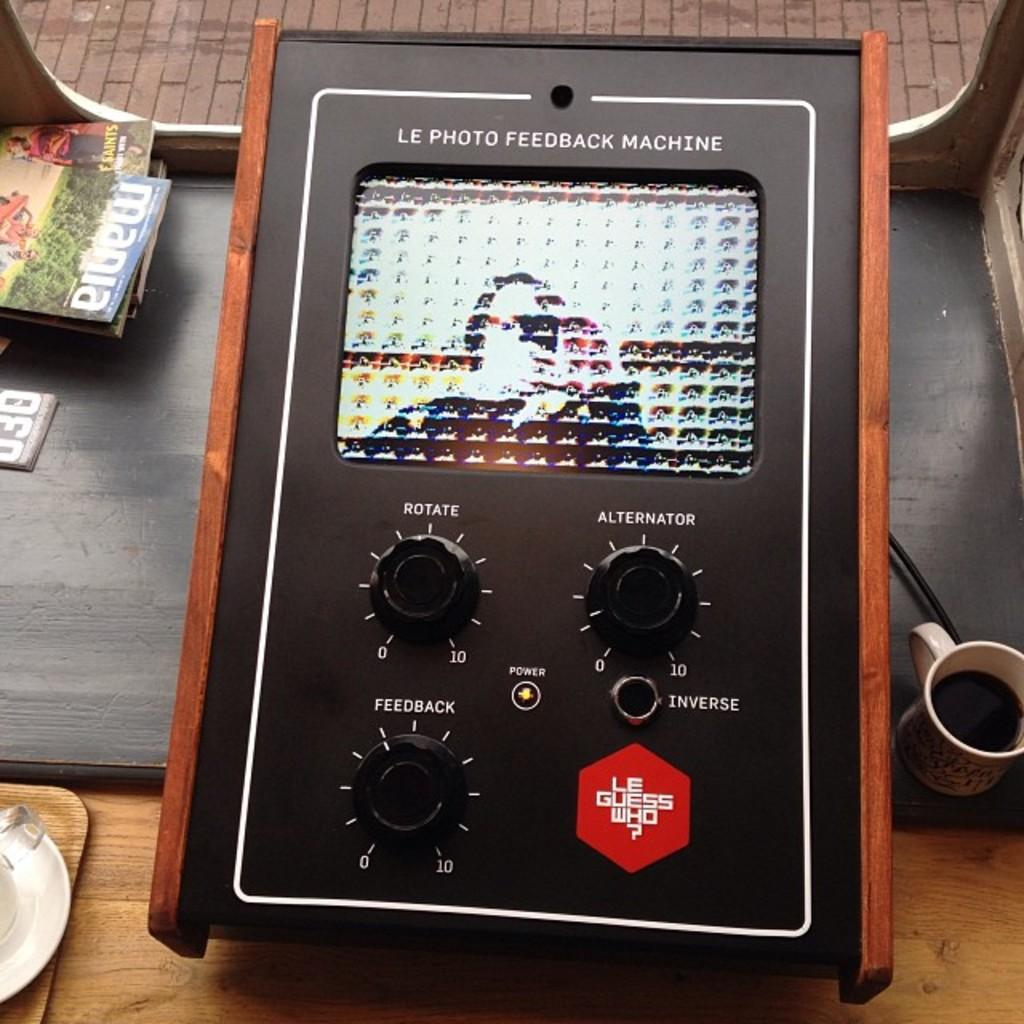<image>
Provide a brief description of the given image. Le Photo Feedback Machine with black dials and wooden edges is on a table. 